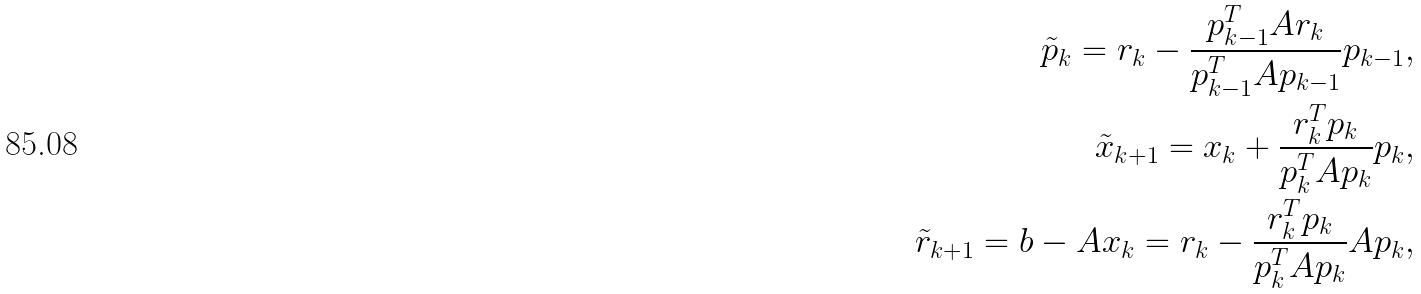Convert formula to latex. <formula><loc_0><loc_0><loc_500><loc_500>\tilde { p } _ { k } = r _ { k } - \frac { p _ { k - 1 } ^ { T } A r _ { k } } { p _ { k - 1 } ^ { T } A p _ { k - 1 } } p _ { k - 1 } , \\ \tilde { x } _ { k + 1 } = x _ { k } + \frac { r _ { k } ^ { T } p _ { k } } { p _ { k } ^ { T } A p _ { k } } p _ { k } , \\ \tilde { r } _ { k + 1 } = b - A x _ { k } = r _ { k } - \frac { r _ { k } ^ { T } p _ { k } } { p _ { k } ^ { T } A p _ { k } } A p _ { k } ,</formula> 